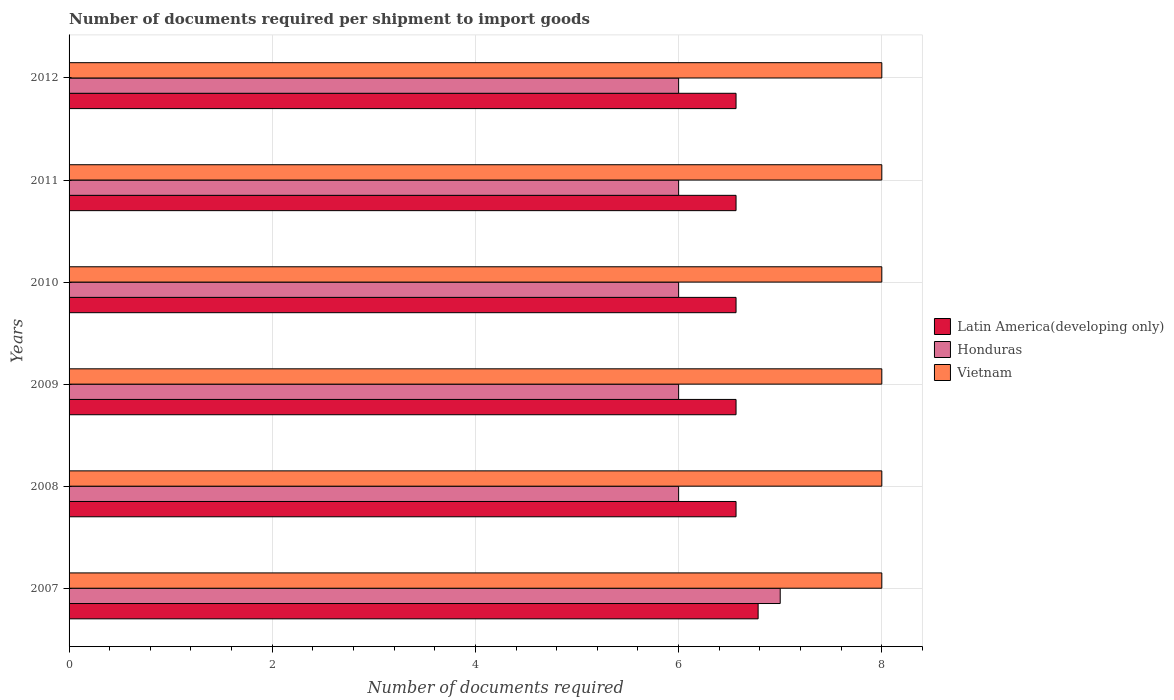Are the number of bars per tick equal to the number of legend labels?
Provide a succinct answer. Yes. Are the number of bars on each tick of the Y-axis equal?
Make the answer very short. Yes. How many bars are there on the 1st tick from the top?
Keep it short and to the point. 3. What is the number of documents required per shipment to import goods in Latin America(developing only) in 2007?
Offer a very short reply. 6.78. Across all years, what is the maximum number of documents required per shipment to import goods in Vietnam?
Your answer should be compact. 8. What is the total number of documents required per shipment to import goods in Latin America(developing only) in the graph?
Offer a very short reply. 39.61. What is the difference between the number of documents required per shipment to import goods in Honduras in 2011 and the number of documents required per shipment to import goods in Vietnam in 2012?
Provide a short and direct response. -2. In the year 2008, what is the difference between the number of documents required per shipment to import goods in Vietnam and number of documents required per shipment to import goods in Latin America(developing only)?
Ensure brevity in your answer.  1.43. In how many years, is the number of documents required per shipment to import goods in Honduras greater than 0.8 ?
Offer a terse response. 6. What is the difference between the highest and the second highest number of documents required per shipment to import goods in Honduras?
Make the answer very short. 1. What is the difference between the highest and the lowest number of documents required per shipment to import goods in Latin America(developing only)?
Keep it short and to the point. 0.22. What does the 2nd bar from the top in 2012 represents?
Your response must be concise. Honduras. What does the 3rd bar from the bottom in 2012 represents?
Offer a very short reply. Vietnam. Are all the bars in the graph horizontal?
Your answer should be compact. Yes. What is the difference between two consecutive major ticks on the X-axis?
Keep it short and to the point. 2. Are the values on the major ticks of X-axis written in scientific E-notation?
Make the answer very short. No. Does the graph contain any zero values?
Provide a succinct answer. No. Does the graph contain grids?
Provide a succinct answer. Yes. Where does the legend appear in the graph?
Make the answer very short. Center right. How many legend labels are there?
Provide a succinct answer. 3. How are the legend labels stacked?
Ensure brevity in your answer.  Vertical. What is the title of the graph?
Your response must be concise. Number of documents required per shipment to import goods. Does "Suriname" appear as one of the legend labels in the graph?
Give a very brief answer. No. What is the label or title of the X-axis?
Your answer should be very brief. Number of documents required. What is the label or title of the Y-axis?
Ensure brevity in your answer.  Years. What is the Number of documents required in Latin America(developing only) in 2007?
Offer a terse response. 6.78. What is the Number of documents required of Vietnam in 2007?
Make the answer very short. 8. What is the Number of documents required in Latin America(developing only) in 2008?
Provide a succinct answer. 6.57. What is the Number of documents required of Latin America(developing only) in 2009?
Your answer should be compact. 6.57. What is the Number of documents required in Honduras in 2009?
Your response must be concise. 6. What is the Number of documents required of Vietnam in 2009?
Your answer should be very brief. 8. What is the Number of documents required of Latin America(developing only) in 2010?
Your response must be concise. 6.57. What is the Number of documents required in Latin America(developing only) in 2011?
Your answer should be compact. 6.57. What is the Number of documents required in Honduras in 2011?
Provide a short and direct response. 6. What is the Number of documents required of Vietnam in 2011?
Make the answer very short. 8. What is the Number of documents required of Latin America(developing only) in 2012?
Your answer should be compact. 6.57. Across all years, what is the maximum Number of documents required in Latin America(developing only)?
Ensure brevity in your answer.  6.78. Across all years, what is the maximum Number of documents required in Honduras?
Offer a terse response. 7. Across all years, what is the maximum Number of documents required in Vietnam?
Keep it short and to the point. 8. Across all years, what is the minimum Number of documents required of Latin America(developing only)?
Keep it short and to the point. 6.57. Across all years, what is the minimum Number of documents required of Honduras?
Provide a succinct answer. 6. Across all years, what is the minimum Number of documents required of Vietnam?
Provide a short and direct response. 8. What is the total Number of documents required in Latin America(developing only) in the graph?
Offer a very short reply. 39.61. What is the total Number of documents required of Honduras in the graph?
Offer a terse response. 37. What is the total Number of documents required of Vietnam in the graph?
Make the answer very short. 48. What is the difference between the Number of documents required of Latin America(developing only) in 2007 and that in 2008?
Ensure brevity in your answer.  0.22. What is the difference between the Number of documents required of Vietnam in 2007 and that in 2008?
Your response must be concise. 0. What is the difference between the Number of documents required of Latin America(developing only) in 2007 and that in 2009?
Your response must be concise. 0.22. What is the difference between the Number of documents required of Honduras in 2007 and that in 2009?
Provide a short and direct response. 1. What is the difference between the Number of documents required of Vietnam in 2007 and that in 2009?
Keep it short and to the point. 0. What is the difference between the Number of documents required in Latin America(developing only) in 2007 and that in 2010?
Your response must be concise. 0.22. What is the difference between the Number of documents required in Honduras in 2007 and that in 2010?
Your response must be concise. 1. What is the difference between the Number of documents required of Latin America(developing only) in 2007 and that in 2011?
Provide a succinct answer. 0.22. What is the difference between the Number of documents required of Vietnam in 2007 and that in 2011?
Provide a short and direct response. 0. What is the difference between the Number of documents required of Latin America(developing only) in 2007 and that in 2012?
Your answer should be very brief. 0.22. What is the difference between the Number of documents required in Honduras in 2007 and that in 2012?
Ensure brevity in your answer.  1. What is the difference between the Number of documents required of Vietnam in 2007 and that in 2012?
Provide a short and direct response. 0. What is the difference between the Number of documents required in Latin America(developing only) in 2008 and that in 2009?
Your answer should be compact. 0. What is the difference between the Number of documents required of Honduras in 2008 and that in 2009?
Offer a terse response. 0. What is the difference between the Number of documents required of Latin America(developing only) in 2008 and that in 2010?
Your answer should be very brief. 0. What is the difference between the Number of documents required of Honduras in 2008 and that in 2010?
Ensure brevity in your answer.  0. What is the difference between the Number of documents required in Latin America(developing only) in 2008 and that in 2011?
Make the answer very short. 0. What is the difference between the Number of documents required in Honduras in 2008 and that in 2011?
Your answer should be very brief. 0. What is the difference between the Number of documents required of Vietnam in 2008 and that in 2011?
Give a very brief answer. 0. What is the difference between the Number of documents required in Latin America(developing only) in 2008 and that in 2012?
Ensure brevity in your answer.  0. What is the difference between the Number of documents required in Vietnam in 2008 and that in 2012?
Your response must be concise. 0. What is the difference between the Number of documents required in Latin America(developing only) in 2009 and that in 2010?
Make the answer very short. 0. What is the difference between the Number of documents required of Honduras in 2009 and that in 2010?
Provide a short and direct response. 0. What is the difference between the Number of documents required of Latin America(developing only) in 2009 and that in 2011?
Make the answer very short. 0. What is the difference between the Number of documents required of Vietnam in 2009 and that in 2011?
Your response must be concise. 0. What is the difference between the Number of documents required in Latin America(developing only) in 2009 and that in 2012?
Keep it short and to the point. 0. What is the difference between the Number of documents required in Honduras in 2009 and that in 2012?
Your answer should be compact. 0. What is the difference between the Number of documents required in Vietnam in 2009 and that in 2012?
Offer a very short reply. 0. What is the difference between the Number of documents required of Vietnam in 2010 and that in 2011?
Your response must be concise. 0. What is the difference between the Number of documents required in Vietnam in 2010 and that in 2012?
Ensure brevity in your answer.  0. What is the difference between the Number of documents required of Honduras in 2011 and that in 2012?
Your response must be concise. 0. What is the difference between the Number of documents required in Vietnam in 2011 and that in 2012?
Provide a succinct answer. 0. What is the difference between the Number of documents required of Latin America(developing only) in 2007 and the Number of documents required of Honduras in 2008?
Keep it short and to the point. 0.78. What is the difference between the Number of documents required in Latin America(developing only) in 2007 and the Number of documents required in Vietnam in 2008?
Give a very brief answer. -1.22. What is the difference between the Number of documents required of Honduras in 2007 and the Number of documents required of Vietnam in 2008?
Provide a succinct answer. -1. What is the difference between the Number of documents required of Latin America(developing only) in 2007 and the Number of documents required of Honduras in 2009?
Provide a short and direct response. 0.78. What is the difference between the Number of documents required in Latin America(developing only) in 2007 and the Number of documents required in Vietnam in 2009?
Give a very brief answer. -1.22. What is the difference between the Number of documents required in Latin America(developing only) in 2007 and the Number of documents required in Honduras in 2010?
Your answer should be compact. 0.78. What is the difference between the Number of documents required of Latin America(developing only) in 2007 and the Number of documents required of Vietnam in 2010?
Offer a very short reply. -1.22. What is the difference between the Number of documents required in Honduras in 2007 and the Number of documents required in Vietnam in 2010?
Keep it short and to the point. -1. What is the difference between the Number of documents required of Latin America(developing only) in 2007 and the Number of documents required of Honduras in 2011?
Provide a short and direct response. 0.78. What is the difference between the Number of documents required in Latin America(developing only) in 2007 and the Number of documents required in Vietnam in 2011?
Provide a short and direct response. -1.22. What is the difference between the Number of documents required of Honduras in 2007 and the Number of documents required of Vietnam in 2011?
Provide a succinct answer. -1. What is the difference between the Number of documents required of Latin America(developing only) in 2007 and the Number of documents required of Honduras in 2012?
Make the answer very short. 0.78. What is the difference between the Number of documents required of Latin America(developing only) in 2007 and the Number of documents required of Vietnam in 2012?
Offer a terse response. -1.22. What is the difference between the Number of documents required in Latin America(developing only) in 2008 and the Number of documents required in Honduras in 2009?
Offer a terse response. 0.57. What is the difference between the Number of documents required of Latin America(developing only) in 2008 and the Number of documents required of Vietnam in 2009?
Your answer should be compact. -1.43. What is the difference between the Number of documents required in Honduras in 2008 and the Number of documents required in Vietnam in 2009?
Provide a short and direct response. -2. What is the difference between the Number of documents required in Latin America(developing only) in 2008 and the Number of documents required in Honduras in 2010?
Make the answer very short. 0.57. What is the difference between the Number of documents required of Latin America(developing only) in 2008 and the Number of documents required of Vietnam in 2010?
Give a very brief answer. -1.43. What is the difference between the Number of documents required of Latin America(developing only) in 2008 and the Number of documents required of Honduras in 2011?
Give a very brief answer. 0.57. What is the difference between the Number of documents required in Latin America(developing only) in 2008 and the Number of documents required in Vietnam in 2011?
Make the answer very short. -1.43. What is the difference between the Number of documents required in Latin America(developing only) in 2008 and the Number of documents required in Honduras in 2012?
Make the answer very short. 0.57. What is the difference between the Number of documents required of Latin America(developing only) in 2008 and the Number of documents required of Vietnam in 2012?
Keep it short and to the point. -1.43. What is the difference between the Number of documents required of Latin America(developing only) in 2009 and the Number of documents required of Honduras in 2010?
Your answer should be very brief. 0.57. What is the difference between the Number of documents required of Latin America(developing only) in 2009 and the Number of documents required of Vietnam in 2010?
Provide a short and direct response. -1.43. What is the difference between the Number of documents required of Honduras in 2009 and the Number of documents required of Vietnam in 2010?
Ensure brevity in your answer.  -2. What is the difference between the Number of documents required of Latin America(developing only) in 2009 and the Number of documents required of Honduras in 2011?
Offer a very short reply. 0.57. What is the difference between the Number of documents required in Latin America(developing only) in 2009 and the Number of documents required in Vietnam in 2011?
Offer a very short reply. -1.43. What is the difference between the Number of documents required in Honduras in 2009 and the Number of documents required in Vietnam in 2011?
Your answer should be very brief. -2. What is the difference between the Number of documents required of Latin America(developing only) in 2009 and the Number of documents required of Honduras in 2012?
Offer a very short reply. 0.57. What is the difference between the Number of documents required of Latin America(developing only) in 2009 and the Number of documents required of Vietnam in 2012?
Make the answer very short. -1.43. What is the difference between the Number of documents required of Latin America(developing only) in 2010 and the Number of documents required of Honduras in 2011?
Ensure brevity in your answer.  0.57. What is the difference between the Number of documents required in Latin America(developing only) in 2010 and the Number of documents required in Vietnam in 2011?
Your answer should be compact. -1.43. What is the difference between the Number of documents required in Honduras in 2010 and the Number of documents required in Vietnam in 2011?
Offer a very short reply. -2. What is the difference between the Number of documents required in Latin America(developing only) in 2010 and the Number of documents required in Honduras in 2012?
Provide a succinct answer. 0.57. What is the difference between the Number of documents required in Latin America(developing only) in 2010 and the Number of documents required in Vietnam in 2012?
Your answer should be very brief. -1.43. What is the difference between the Number of documents required in Latin America(developing only) in 2011 and the Number of documents required in Honduras in 2012?
Ensure brevity in your answer.  0.57. What is the difference between the Number of documents required in Latin America(developing only) in 2011 and the Number of documents required in Vietnam in 2012?
Your answer should be compact. -1.43. What is the average Number of documents required in Latin America(developing only) per year?
Ensure brevity in your answer.  6.6. What is the average Number of documents required in Honduras per year?
Ensure brevity in your answer.  6.17. In the year 2007, what is the difference between the Number of documents required in Latin America(developing only) and Number of documents required in Honduras?
Make the answer very short. -0.22. In the year 2007, what is the difference between the Number of documents required in Latin America(developing only) and Number of documents required in Vietnam?
Offer a very short reply. -1.22. In the year 2007, what is the difference between the Number of documents required in Honduras and Number of documents required in Vietnam?
Your response must be concise. -1. In the year 2008, what is the difference between the Number of documents required in Latin America(developing only) and Number of documents required in Honduras?
Make the answer very short. 0.57. In the year 2008, what is the difference between the Number of documents required in Latin America(developing only) and Number of documents required in Vietnam?
Provide a succinct answer. -1.43. In the year 2009, what is the difference between the Number of documents required of Latin America(developing only) and Number of documents required of Honduras?
Make the answer very short. 0.57. In the year 2009, what is the difference between the Number of documents required in Latin America(developing only) and Number of documents required in Vietnam?
Your answer should be compact. -1.43. In the year 2009, what is the difference between the Number of documents required of Honduras and Number of documents required of Vietnam?
Make the answer very short. -2. In the year 2010, what is the difference between the Number of documents required in Latin America(developing only) and Number of documents required in Honduras?
Ensure brevity in your answer.  0.57. In the year 2010, what is the difference between the Number of documents required of Latin America(developing only) and Number of documents required of Vietnam?
Offer a terse response. -1.43. In the year 2011, what is the difference between the Number of documents required of Latin America(developing only) and Number of documents required of Honduras?
Provide a succinct answer. 0.57. In the year 2011, what is the difference between the Number of documents required in Latin America(developing only) and Number of documents required in Vietnam?
Your answer should be compact. -1.43. In the year 2012, what is the difference between the Number of documents required in Latin America(developing only) and Number of documents required in Honduras?
Ensure brevity in your answer.  0.57. In the year 2012, what is the difference between the Number of documents required in Latin America(developing only) and Number of documents required in Vietnam?
Your answer should be very brief. -1.43. What is the ratio of the Number of documents required of Latin America(developing only) in 2007 to that in 2008?
Provide a succinct answer. 1.03. What is the ratio of the Number of documents required of Honduras in 2007 to that in 2008?
Ensure brevity in your answer.  1.17. What is the ratio of the Number of documents required in Vietnam in 2007 to that in 2008?
Give a very brief answer. 1. What is the ratio of the Number of documents required in Latin America(developing only) in 2007 to that in 2009?
Offer a terse response. 1.03. What is the ratio of the Number of documents required of Vietnam in 2007 to that in 2009?
Your answer should be compact. 1. What is the ratio of the Number of documents required of Latin America(developing only) in 2007 to that in 2010?
Provide a succinct answer. 1.03. What is the ratio of the Number of documents required of Latin America(developing only) in 2007 to that in 2011?
Provide a succinct answer. 1.03. What is the ratio of the Number of documents required in Honduras in 2007 to that in 2011?
Offer a very short reply. 1.17. What is the ratio of the Number of documents required of Latin America(developing only) in 2007 to that in 2012?
Keep it short and to the point. 1.03. What is the ratio of the Number of documents required of Latin America(developing only) in 2008 to that in 2009?
Your answer should be compact. 1. What is the ratio of the Number of documents required of Vietnam in 2008 to that in 2009?
Provide a succinct answer. 1. What is the ratio of the Number of documents required in Honduras in 2008 to that in 2010?
Your answer should be compact. 1. What is the ratio of the Number of documents required in Vietnam in 2008 to that in 2010?
Give a very brief answer. 1. What is the ratio of the Number of documents required in Latin America(developing only) in 2008 to that in 2011?
Provide a succinct answer. 1. What is the ratio of the Number of documents required of Honduras in 2008 to that in 2011?
Offer a very short reply. 1. What is the ratio of the Number of documents required in Honduras in 2008 to that in 2012?
Your answer should be compact. 1. What is the ratio of the Number of documents required in Honduras in 2009 to that in 2010?
Give a very brief answer. 1. What is the ratio of the Number of documents required in Vietnam in 2009 to that in 2010?
Your response must be concise. 1. What is the ratio of the Number of documents required of Latin America(developing only) in 2009 to that in 2011?
Your answer should be compact. 1. What is the ratio of the Number of documents required in Honduras in 2009 to that in 2011?
Your response must be concise. 1. What is the ratio of the Number of documents required in Honduras in 2009 to that in 2012?
Make the answer very short. 1. What is the ratio of the Number of documents required of Vietnam in 2009 to that in 2012?
Make the answer very short. 1. What is the ratio of the Number of documents required of Honduras in 2010 to that in 2011?
Keep it short and to the point. 1. What is the ratio of the Number of documents required of Vietnam in 2010 to that in 2011?
Ensure brevity in your answer.  1. What is the ratio of the Number of documents required in Honduras in 2010 to that in 2012?
Offer a terse response. 1. What is the ratio of the Number of documents required of Latin America(developing only) in 2011 to that in 2012?
Your answer should be compact. 1. What is the difference between the highest and the second highest Number of documents required in Latin America(developing only)?
Your answer should be very brief. 0.22. What is the difference between the highest and the second highest Number of documents required of Vietnam?
Give a very brief answer. 0. What is the difference between the highest and the lowest Number of documents required in Latin America(developing only)?
Your answer should be very brief. 0.22. What is the difference between the highest and the lowest Number of documents required in Honduras?
Provide a succinct answer. 1. 